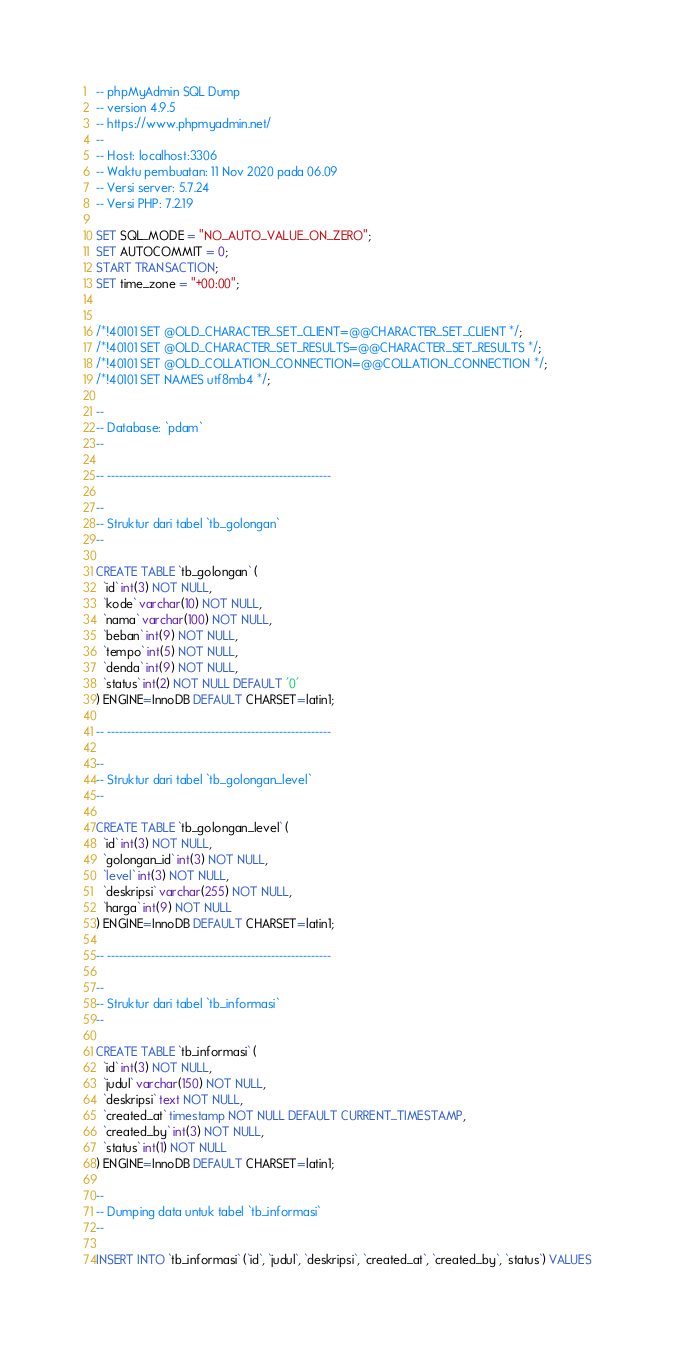<code> <loc_0><loc_0><loc_500><loc_500><_SQL_>-- phpMyAdmin SQL Dump
-- version 4.9.5
-- https://www.phpmyadmin.net/
--
-- Host: localhost:3306
-- Waktu pembuatan: 11 Nov 2020 pada 06.09
-- Versi server: 5.7.24
-- Versi PHP: 7.2.19

SET SQL_MODE = "NO_AUTO_VALUE_ON_ZERO";
SET AUTOCOMMIT = 0;
START TRANSACTION;
SET time_zone = "+00:00";


/*!40101 SET @OLD_CHARACTER_SET_CLIENT=@@CHARACTER_SET_CLIENT */;
/*!40101 SET @OLD_CHARACTER_SET_RESULTS=@@CHARACTER_SET_RESULTS */;
/*!40101 SET @OLD_COLLATION_CONNECTION=@@COLLATION_CONNECTION */;
/*!40101 SET NAMES utf8mb4 */;

--
-- Database: `pdam`
--

-- --------------------------------------------------------

--
-- Struktur dari tabel `tb_golongan`
--

CREATE TABLE `tb_golongan` (
  `id` int(3) NOT NULL,
  `kode` varchar(10) NOT NULL,
  `nama` varchar(100) NOT NULL,
  `beban` int(9) NOT NULL,
  `tempo` int(5) NOT NULL,
  `denda` int(9) NOT NULL,
  `status` int(2) NOT NULL DEFAULT '0'
) ENGINE=InnoDB DEFAULT CHARSET=latin1;

-- --------------------------------------------------------

--
-- Struktur dari tabel `tb_golongan_level`
--

CREATE TABLE `tb_golongan_level` (
  `id` int(3) NOT NULL,
  `golongan_id` int(3) NOT NULL,
  `level` int(3) NOT NULL,
  `deskripsi` varchar(255) NOT NULL,
  `harga` int(9) NOT NULL
) ENGINE=InnoDB DEFAULT CHARSET=latin1;

-- --------------------------------------------------------

--
-- Struktur dari tabel `tb_informasi`
--

CREATE TABLE `tb_informasi` (
  `id` int(3) NOT NULL,
  `judul` varchar(150) NOT NULL,
  `deskripsi` text NOT NULL,
  `created_at` timestamp NOT NULL DEFAULT CURRENT_TIMESTAMP,
  `created_by` int(3) NOT NULL,
  `status` int(1) NOT NULL
) ENGINE=InnoDB DEFAULT CHARSET=latin1;

--
-- Dumping data untuk tabel `tb_informasi`
--

INSERT INTO `tb_informasi` (`id`, `judul`, `deskripsi`, `created_at`, `created_by`, `status`) VALUES</code> 